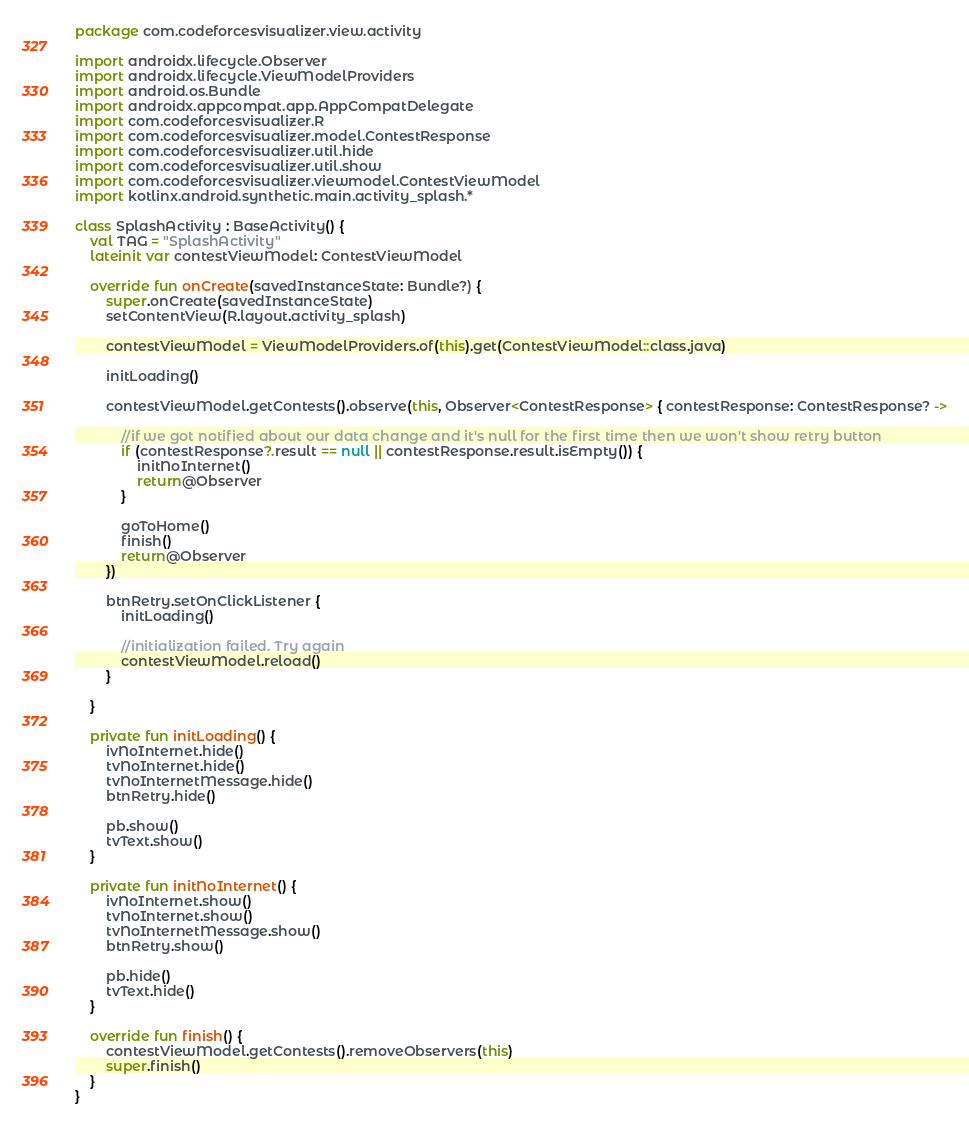Convert code to text. <code><loc_0><loc_0><loc_500><loc_500><_Kotlin_>package com.codeforcesvisualizer.view.activity

import androidx.lifecycle.Observer
import androidx.lifecycle.ViewModelProviders
import android.os.Bundle
import androidx.appcompat.app.AppCompatDelegate
import com.codeforcesvisualizer.R
import com.codeforcesvisualizer.model.ContestResponse
import com.codeforcesvisualizer.util.hide
import com.codeforcesvisualizer.util.show
import com.codeforcesvisualizer.viewmodel.ContestViewModel
import kotlinx.android.synthetic.main.activity_splash.*

class SplashActivity : BaseActivity() {
    val TAG = "SplashActivity"
    lateinit var contestViewModel: ContestViewModel

    override fun onCreate(savedInstanceState: Bundle?) {
        super.onCreate(savedInstanceState)
        setContentView(R.layout.activity_splash)

        contestViewModel = ViewModelProviders.of(this).get(ContestViewModel::class.java)

        initLoading()

        contestViewModel.getContests().observe(this, Observer<ContestResponse> { contestResponse: ContestResponse? ->

            //if we got notified about our data change and it's null for the first time then we won't show retry button
            if (contestResponse?.result == null || contestResponse.result.isEmpty()) {
                initNoInternet()
                return@Observer
            }

            goToHome()
            finish()
            return@Observer
        })

        btnRetry.setOnClickListener {
            initLoading()

            //initialization failed. Try again
            contestViewModel.reload()
        }

    }

    private fun initLoading() {
        ivNoInternet.hide()
        tvNoInternet.hide()
        tvNoInternetMessage.hide()
        btnRetry.hide()

        pb.show()
        tvText.show()
    }

    private fun initNoInternet() {
        ivNoInternet.show()
        tvNoInternet.show()
        tvNoInternetMessage.show()
        btnRetry.show()

        pb.hide()
        tvText.hide()
    }

    override fun finish() {
        contestViewModel.getContests().removeObservers(this)
        super.finish()
    }
}
</code> 